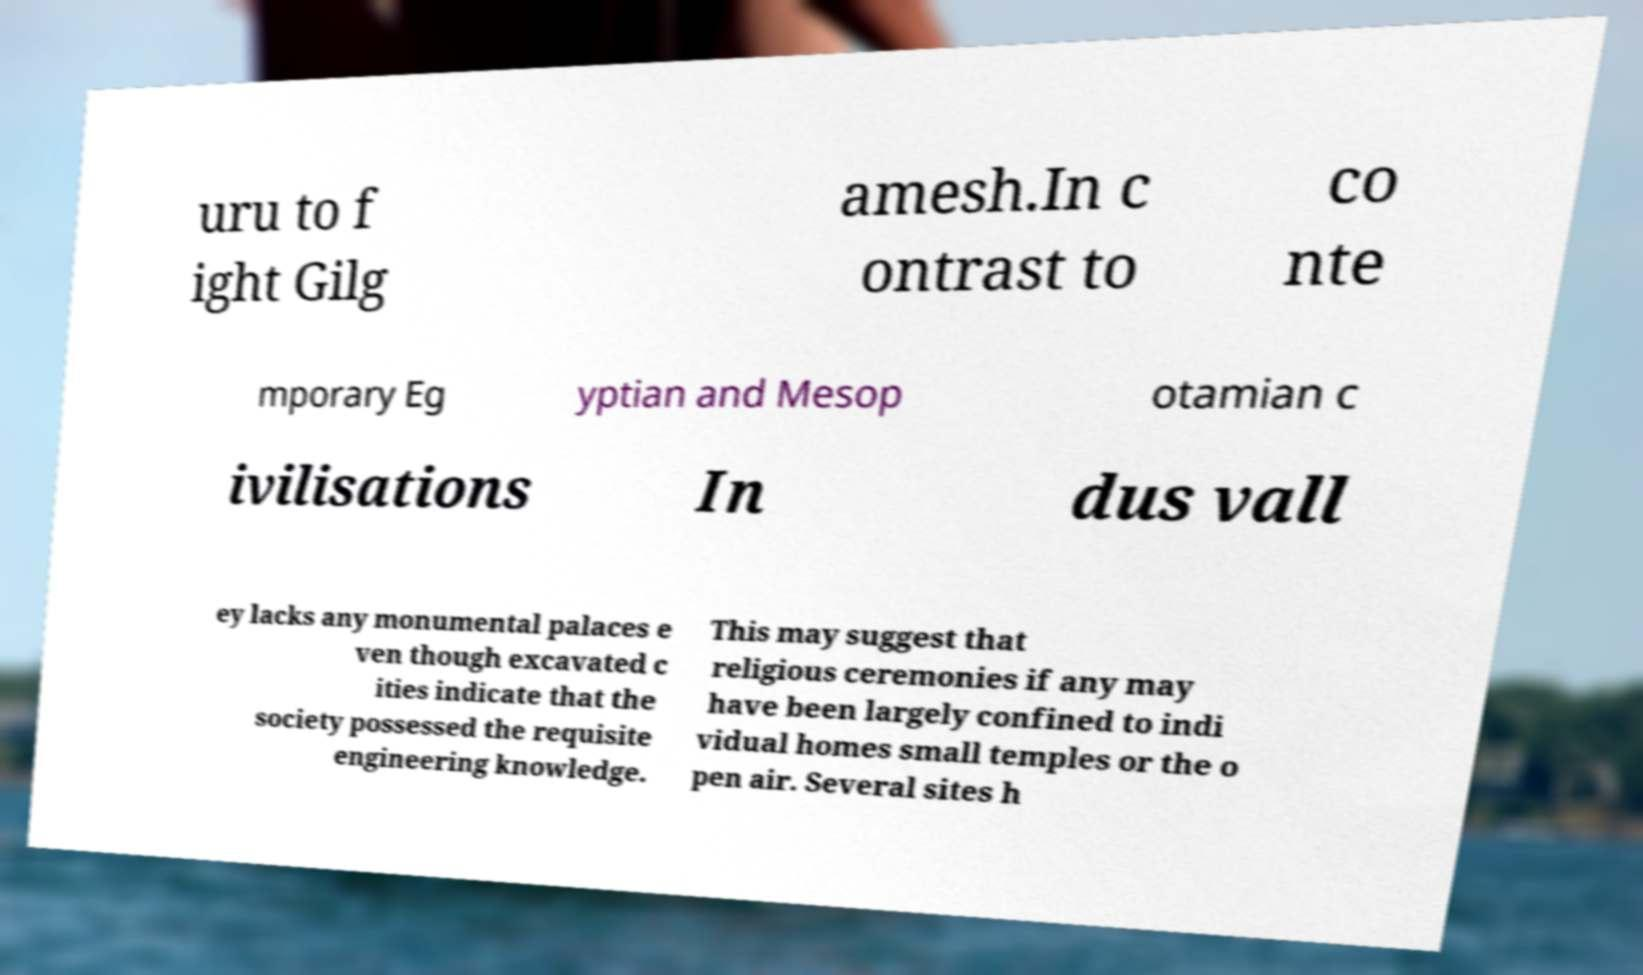There's text embedded in this image that I need extracted. Can you transcribe it verbatim? uru to f ight Gilg amesh.In c ontrast to co nte mporary Eg yptian and Mesop otamian c ivilisations In dus vall ey lacks any monumental palaces e ven though excavated c ities indicate that the society possessed the requisite engineering knowledge. This may suggest that religious ceremonies if any may have been largely confined to indi vidual homes small temples or the o pen air. Several sites h 